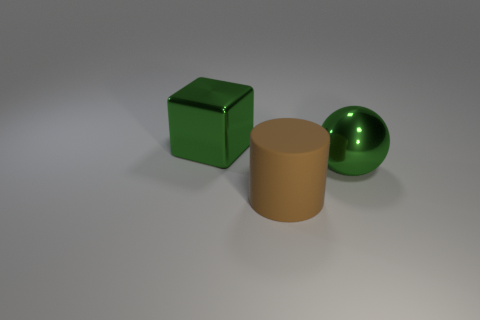There is a large metal sphere; how many shiny balls are to the left of it? 0 